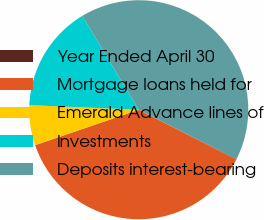<chart> <loc_0><loc_0><loc_500><loc_500><pie_chart><fcel>Year Ended April 30<fcel>Mortgage loans held for<fcel>Emerald Advance lines of<fcel>Investments<fcel>Deposits interest-bearing<nl><fcel>0.09%<fcel>37.23%<fcel>5.91%<fcel>15.71%<fcel>41.05%<nl></chart> 